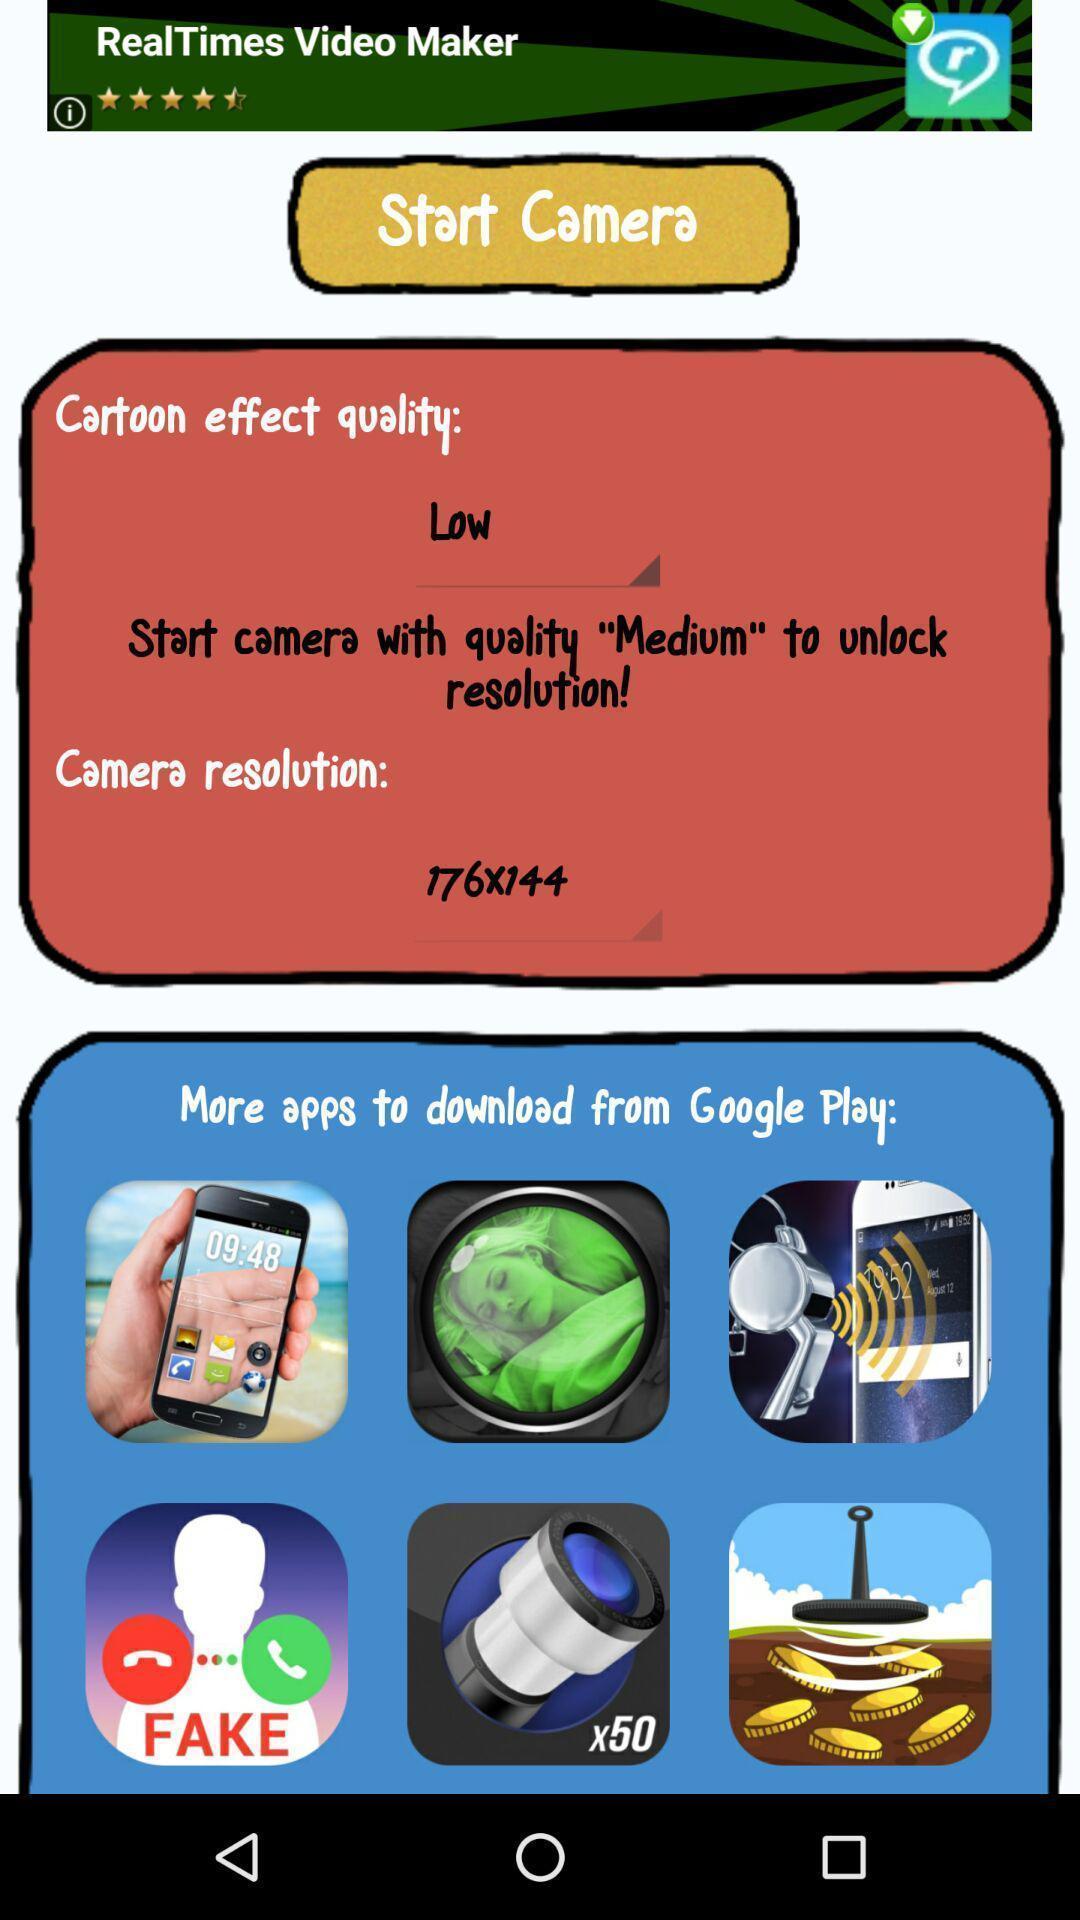What details can you identify in this image? Screen shows different options of camera. 